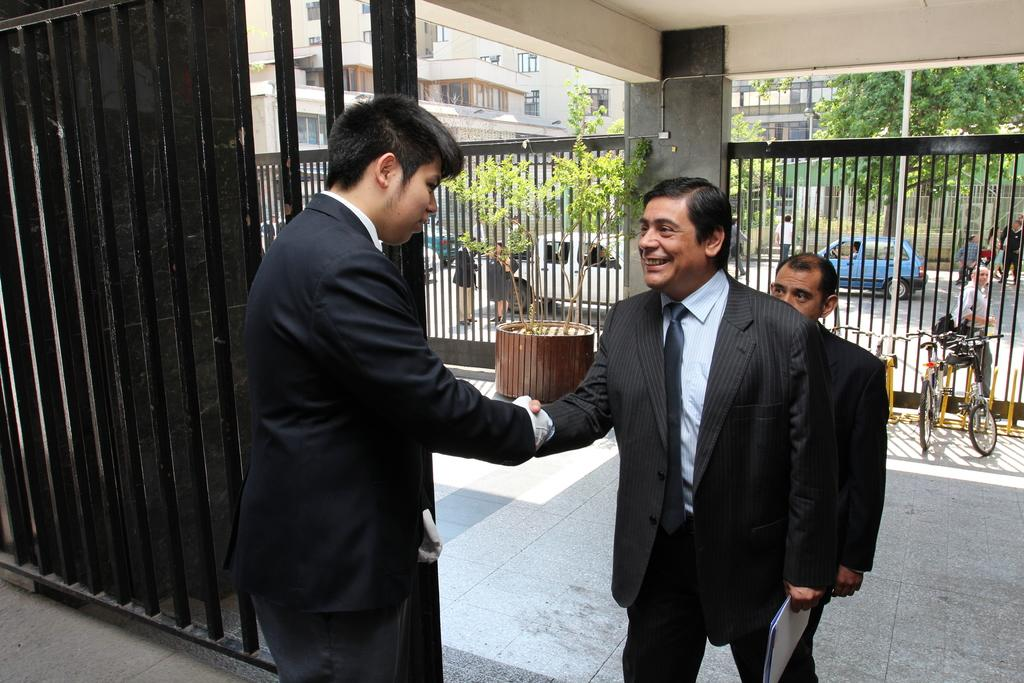What are the persons in the image doing? The persons in the image are standing on the floor and road. What type of transportation can be seen in the image? Bicycles and motor vehicles are visible in the image. What type of vegetation is present in the image? Plants and trees are present in the image. What type of structures are visible in the image? Buildings are visible in the image. What type of cooking equipment is present in the image? Grills are present in the image. What type of street furniture is visible in the image? Street poles are visible in the image. Can you tell me how many goldfish are swimming in the grills in the image? There are no goldfish present in the image, and the grills are not a body of water where fish would swim. 